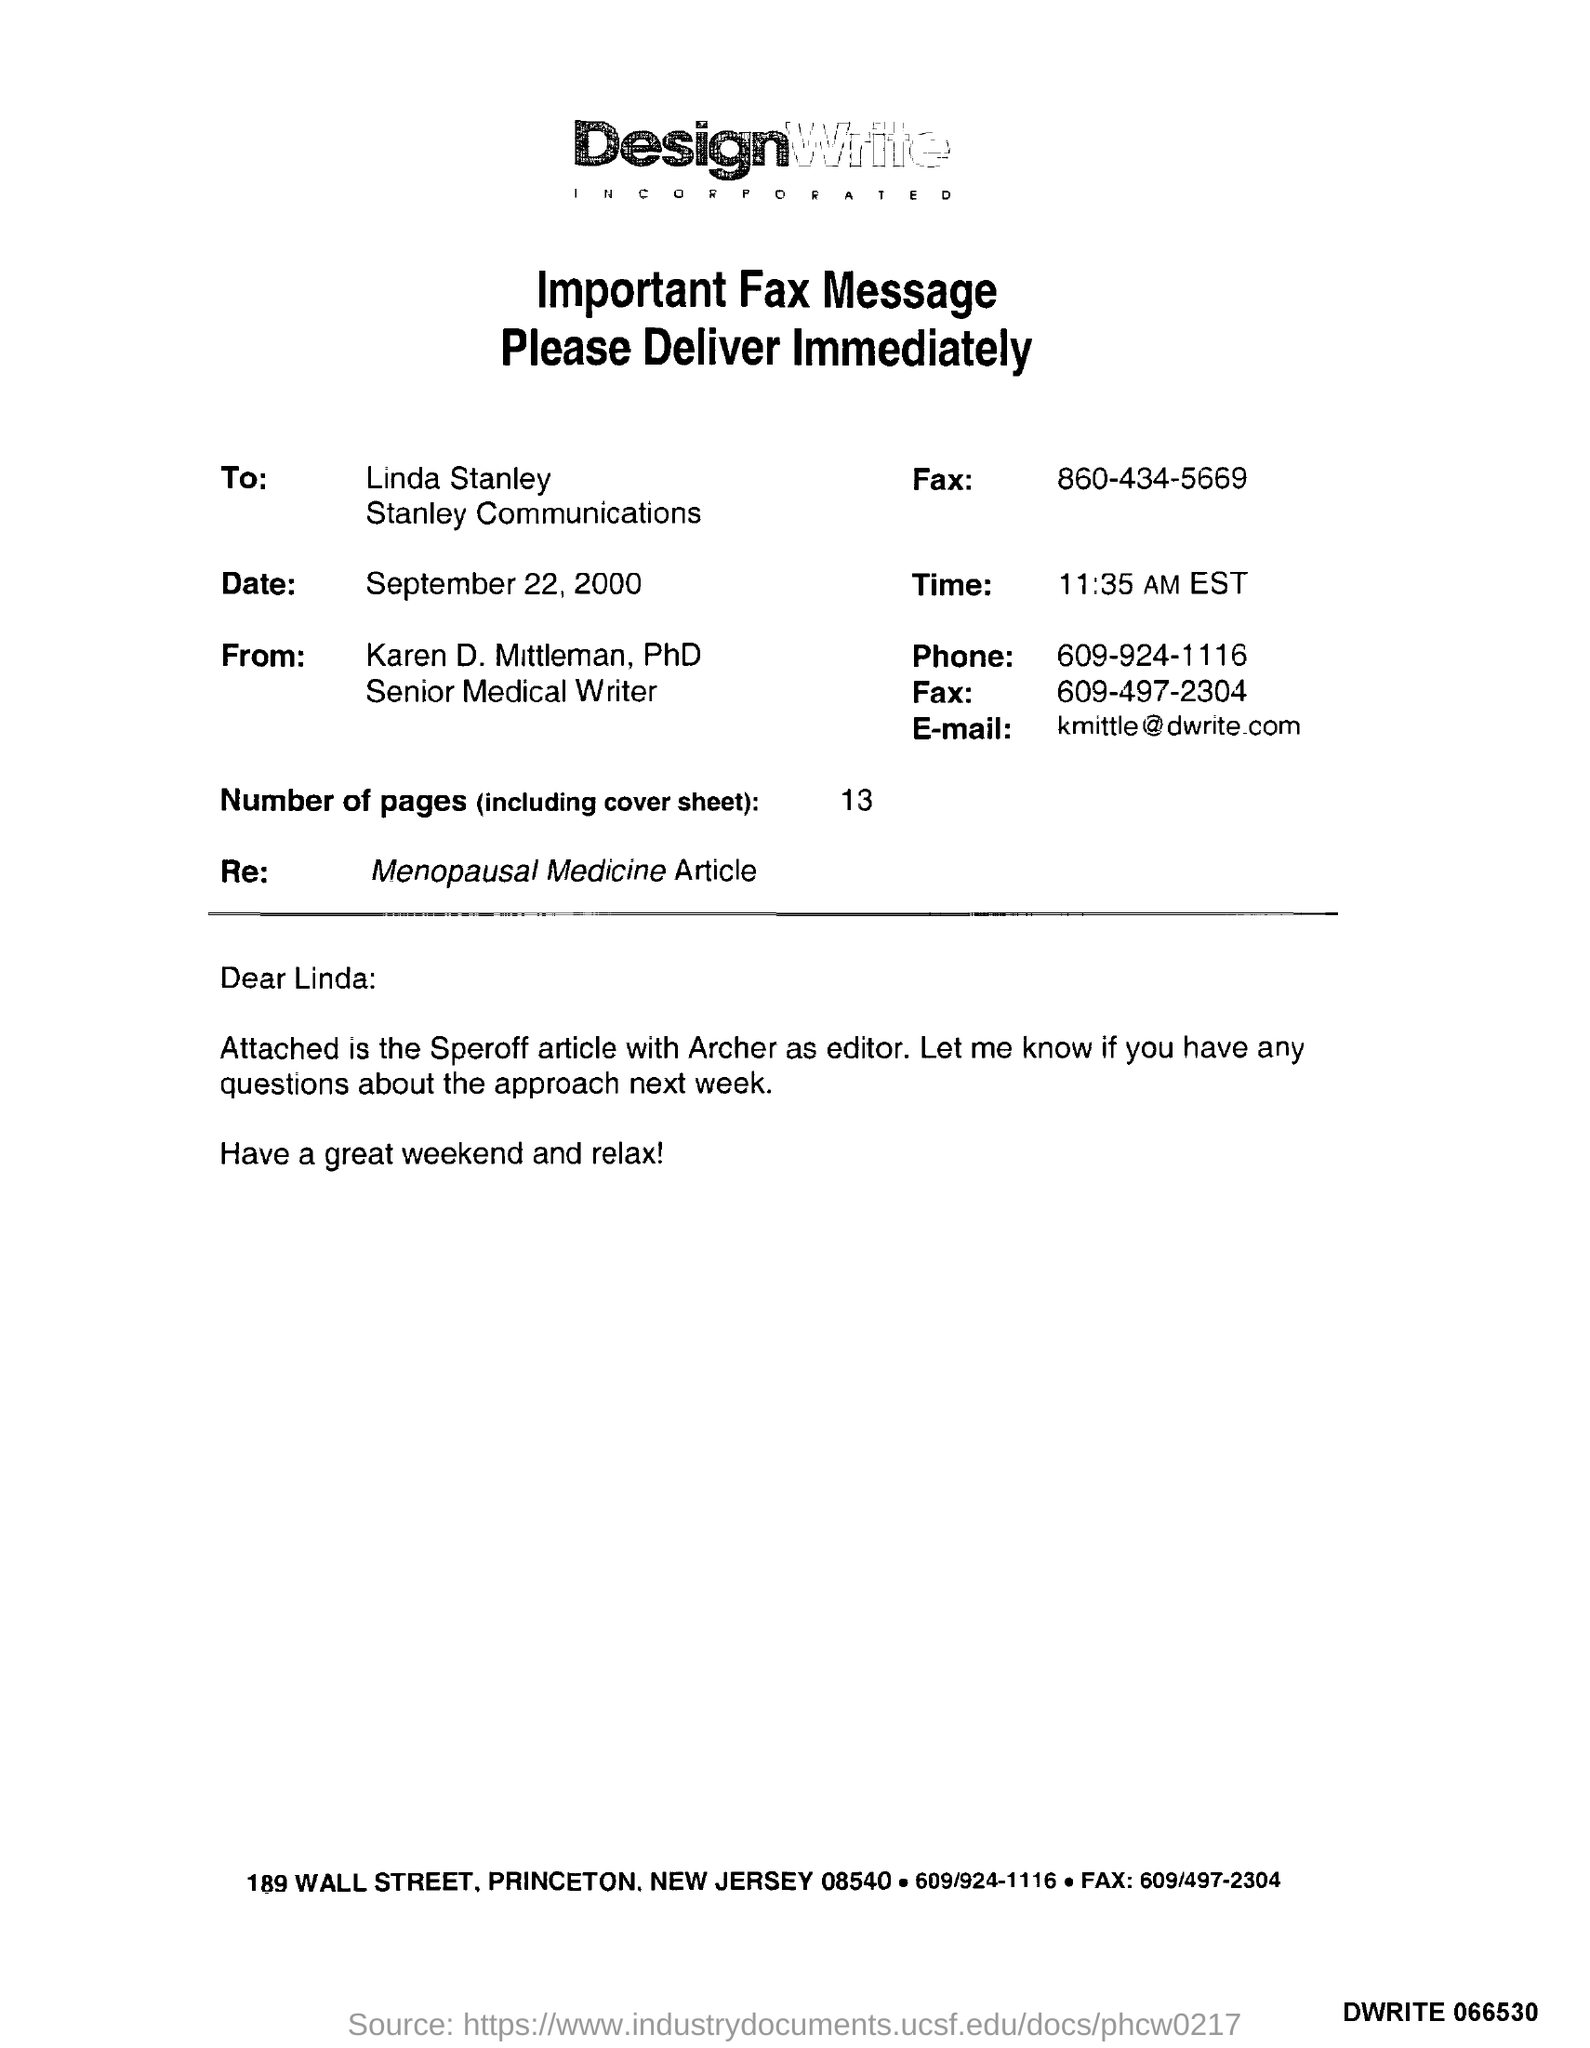Who is the Memorandum addressed to ?
Offer a very short reply. Linda stanley. What is the Receiver Fax Number ?
Your answer should be compact. 860-434-5669. What is the date mentioned in the document ?
Your answer should be very brief. September 22, 2000. What is the Sender Phone Number ?
Your answer should be compact. 609-924-1116. How many Pages are there in this sheet ?
Offer a terse response. 13. Who is the Memorandum from ?
Your response must be concise. Karen D. Mittleman. What is the Sender Fax Number ?
Give a very brief answer. 609-497-2304. What is written in the "Re" field ?
Ensure brevity in your answer.  Menopausal medicine article. 